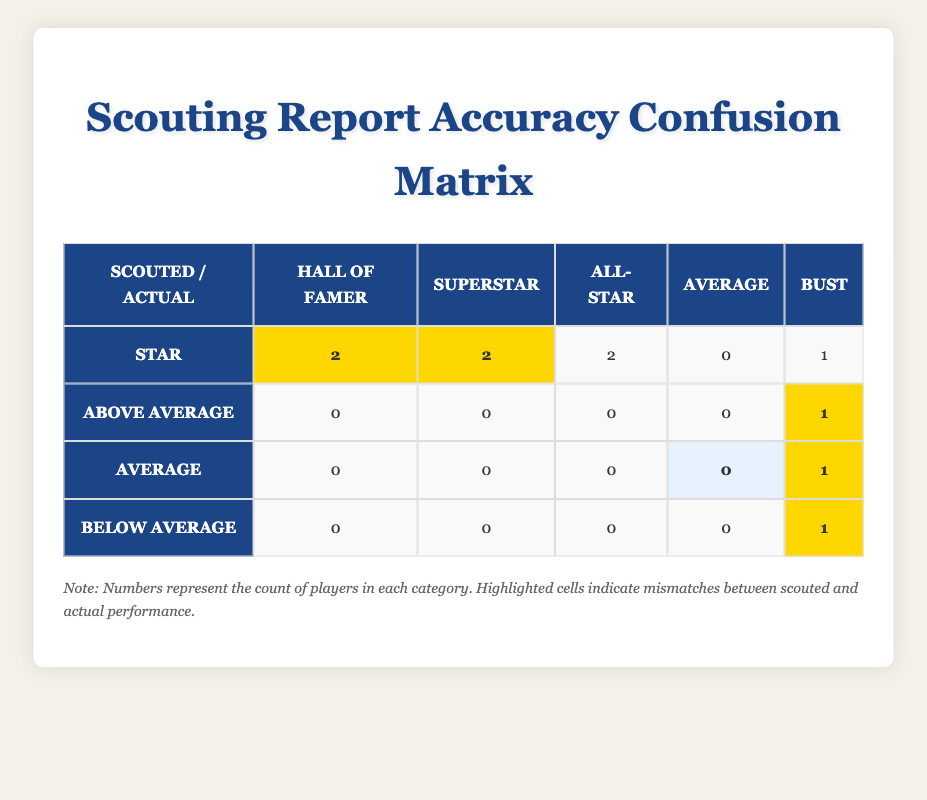What is the total number of players identified as "Star"? Looking at the "Star" row, we can sum the numbers in that row: 2 (Hall of Famer) + 2 (Superstar) + 2 (All-Star) + 0 (Average) + 1 (Bust) = 7 players
Answer: 7 How many players were scouted as "Average"? In the "Average" row, there is 1 player that falls under the "Bust" category. All other categories (Hall of Famer, Superstar, All-Star, Below Average) have a count of 0. Therefore, the number of players scouted as "Average" is simply the count from the row.
Answer: 1 Is it true that there are more players scouted as "Star" than as "Below Average"? Checking the "Star" row, there are 7 players. In the "Below Average" row, there is only 1 player. Since 7 is greater than 1, the answer is yes.
Answer: Yes What is the number of players that were correctly scouted as "Hall of Famer"? Looking at the diagonal cell that corresponds to both "Hall of Famer" and "Star" in the scouting report matrix, there are 2 players. This indicates that the accurate scouting aligns with their actual status
Answer: 2 If we consider only the players scouted as "Bust", how many of them were actually drafted as "Bust"? From the "Bust" row, there are 3 players who were scouted as "Bust." This corresponds to players scouted as "Average" (1) and "Below Average" (1). Thus, we must add those counts in the "Bust" category: Average (0) + Below Average (1) + Bust (1) = 3 players
Answer: 3 What percentage of "Bust" players were scouted as "Average"? The "Bust" row contains 3 players overall: one scouted as "Average," and one as "Below Average." The percentage can be calculated by taking the count of "Average" Bust (1) divided by the total Bust count (3) and multiplying by 100, resulting in (1/3) * 100 = 33.33%.
Answer: 33.33% What is the difference between the number of players scouted as "Star" and "Above Average"? The number of players scouted as "Star" is 7, while the number for "Above Average" is 1. The difference is calculated as 7 (Star) - 1 (Above Average) = 6.
Answer: 6 